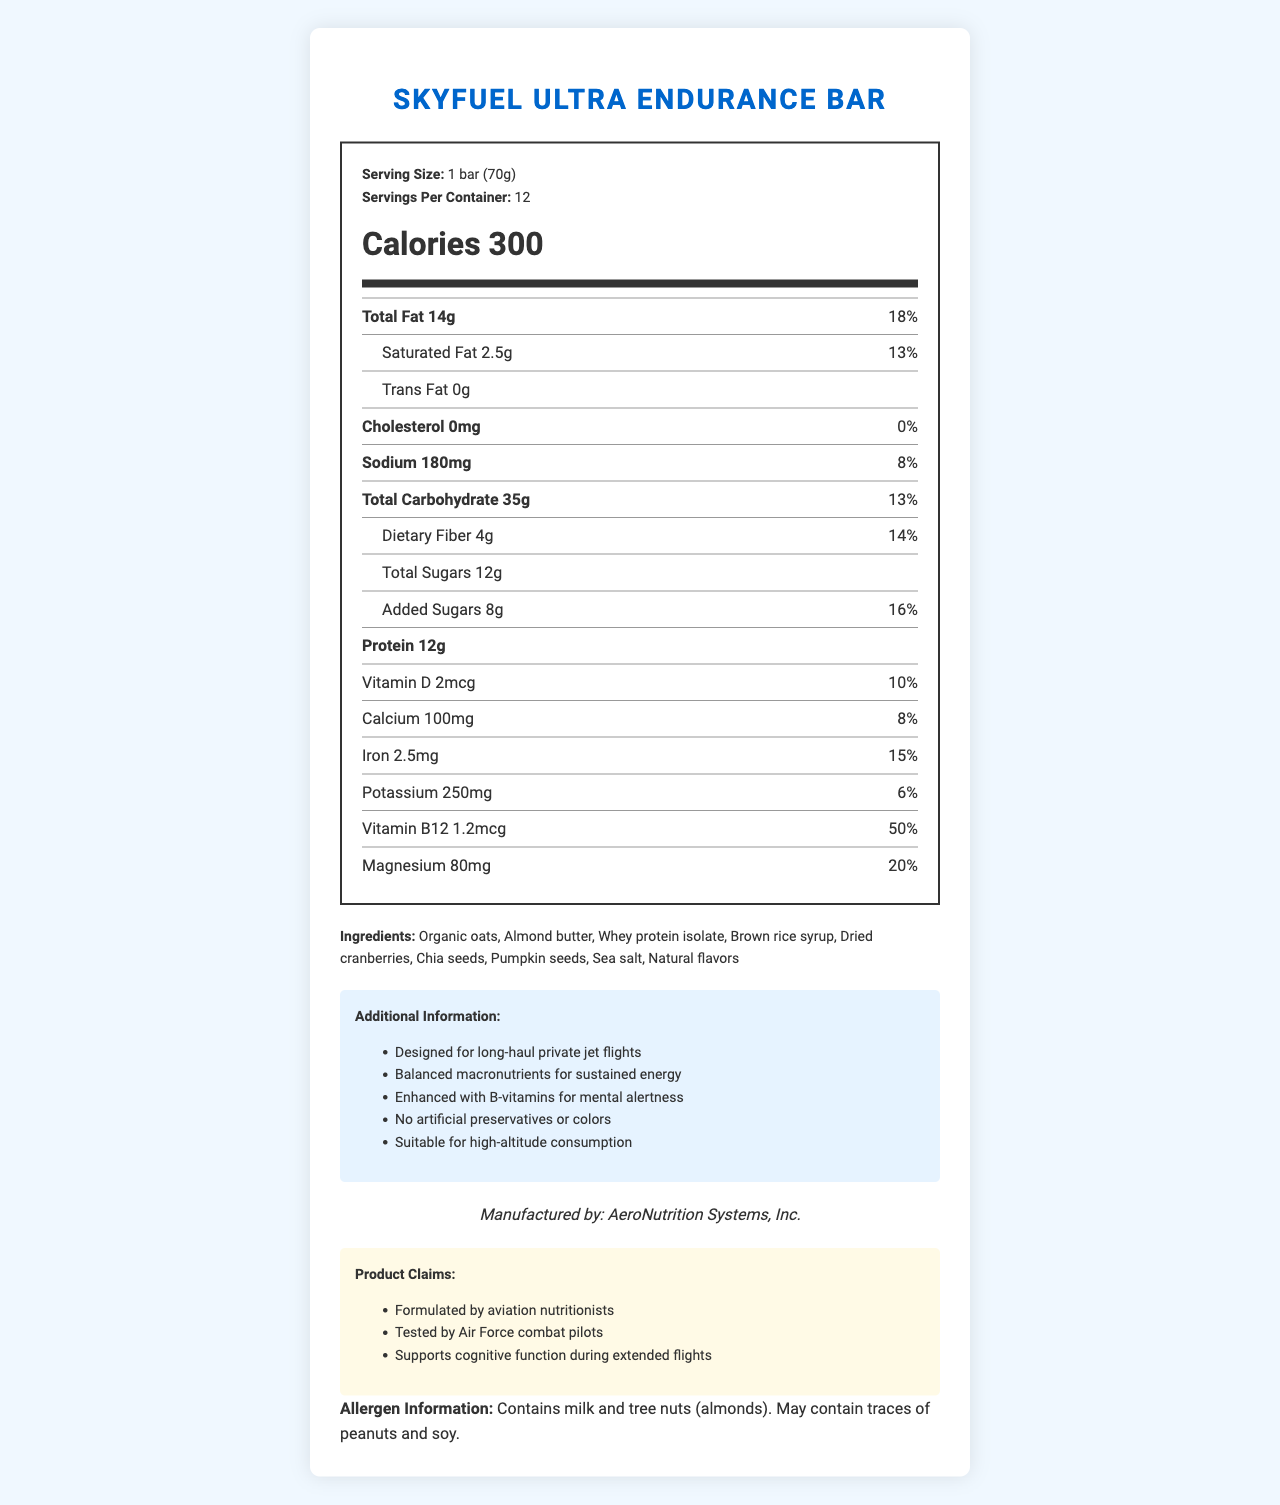From which company is the SkyFuel Ultra Endurance Bar manufactured? The document clearly states "Manufactured by: AeroNutrition Systems, Inc." at the bottom of the rendered document.
Answer: AeroNutrition Systems, Inc. What is the serving size of the SkyFuel Ultra Endurance Bar? This information is provided at the top under the "Serving Size" label.
Answer: 1 bar (70g) How many calories does one SkyFuel Ultra Endurance Bar contain? The calories content is prominently displayed under the "Calories" section in large font.
Answer: 300 calories What is the total amount of fat and its daily value percentage in one bar? The document lists "Total Fat 14g" and "18%" as the daily value right beside it.
Answer: 14g, 18% Does the SkyFuel Ultra Endurance Bar contain any trans fat? The document explicitly states "Trans Fat 0g" indicating there are no trans fats.
Answer: No Which ingredient is NOT listed in the ingredients of the SkyFuel Ultra Endurance Bar? A. Organic oats B. Almond butter C. Chocolate chips D. Pumpkin seeds The ingredients list includes "Organic oats, Almond butter, Whey protein isolate, Brown rice syrup, Dried cranberries, Chia seeds, Pumpkin seeds, Sea salt, Natural flavors" but does not mention chocolate chips.
Answer: C. Chocolate chips How much sodium is in one bar and what is the daily value percentage? The document shows "Sodium 180mg" with a daily value of "8%" next to it.
Answer: 180mg, 8% How much added sugar is in one bar? Under the nutrients section, it lists "Added Sugars 8g".
Answer: 8g Does the product contain any artificial preservatives or colors? In the additional information section, it mentions "No artificial preservatives or colors".
Answer: No What percentage of the daily value for Vitamin B12 does one bar provide? The document states "Vitamin B12 1.2mcg" and "50%" as the daily value.
Answer: 50% What are two claims made about the SkyFuel Ultra Endurance Bar? A. Contains only natural ingredients B. Suitable for high-altitude consumption C. Formulated by dieticians D. Supports cognitive function during extended flights The claims section mentions "Suitable for high-altitude consumption" and "Supports cognitive function during extended flights".
Answer: B, D Does the SkyFuel Ultra Endurance Bar contain any allergens? The allergen information states "Contains milk and tree nuts (almonds). May contain traces of peanuts and soy".
Answer: Yes Summarize the main idea of the document. The document provides comprehensive information about the nutrition facts, ingredients, allergen details, manufacturer, and various product claims for the SkyFuel Ultra Endurance Bar, emphasizing its suitability for long flights and high-altitude conditions.
Answer: The SkyFuel Ultra Endurance Bar is a specially designed nutrition bar for long-haul private jet flights, offering balanced macronutrients and enhanced B-vitamins for sustained energy and mental alertness. It is made with natural ingredients, free from artificial preservatives and colors, and is suitable for high-altitude consumption. Manufactured by AeroNutrition Systems, Inc., it supports cognitive function and has been tested by Air Force combat pilots. What is the price of the SkyFuel Ultra Endurance Bar? The document does not provide any information regarding the pricing of the SkyFuel Ultra Endurance Bar.
Answer: Cannot be determined 